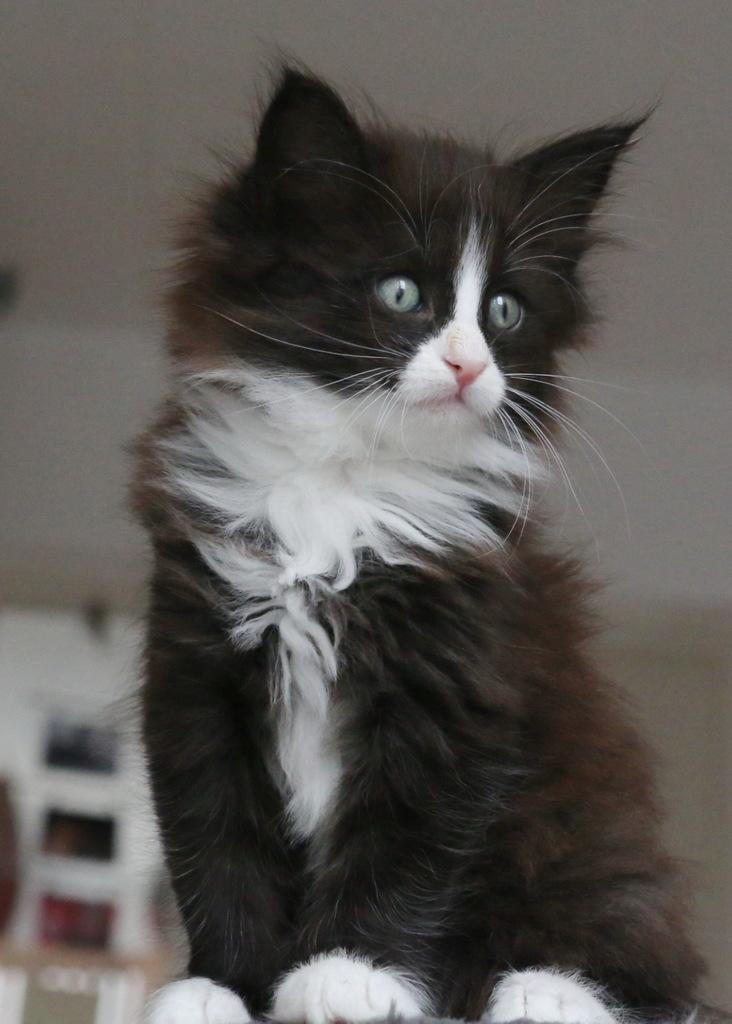What type of animal is in the image? There is a cat in the image. What is the cat doing in the image? The cat is sitting on an object. Can you describe the background of the image? There are blurred items behind the cat. What type of base is the cat using to comb its fur in the image? There is no base or comb present in the image; the cat is simply sitting on an object. 